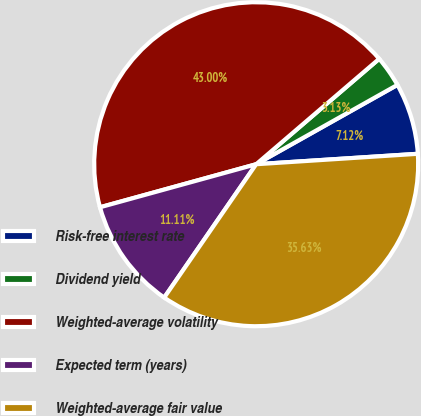Convert chart to OTSL. <chart><loc_0><loc_0><loc_500><loc_500><pie_chart><fcel>Risk-free interest rate<fcel>Dividend yield<fcel>Weighted-average volatility<fcel>Expected term (years)<fcel>Weighted-average fair value<nl><fcel>7.12%<fcel>3.13%<fcel>43.0%<fcel>11.11%<fcel>35.63%<nl></chart> 